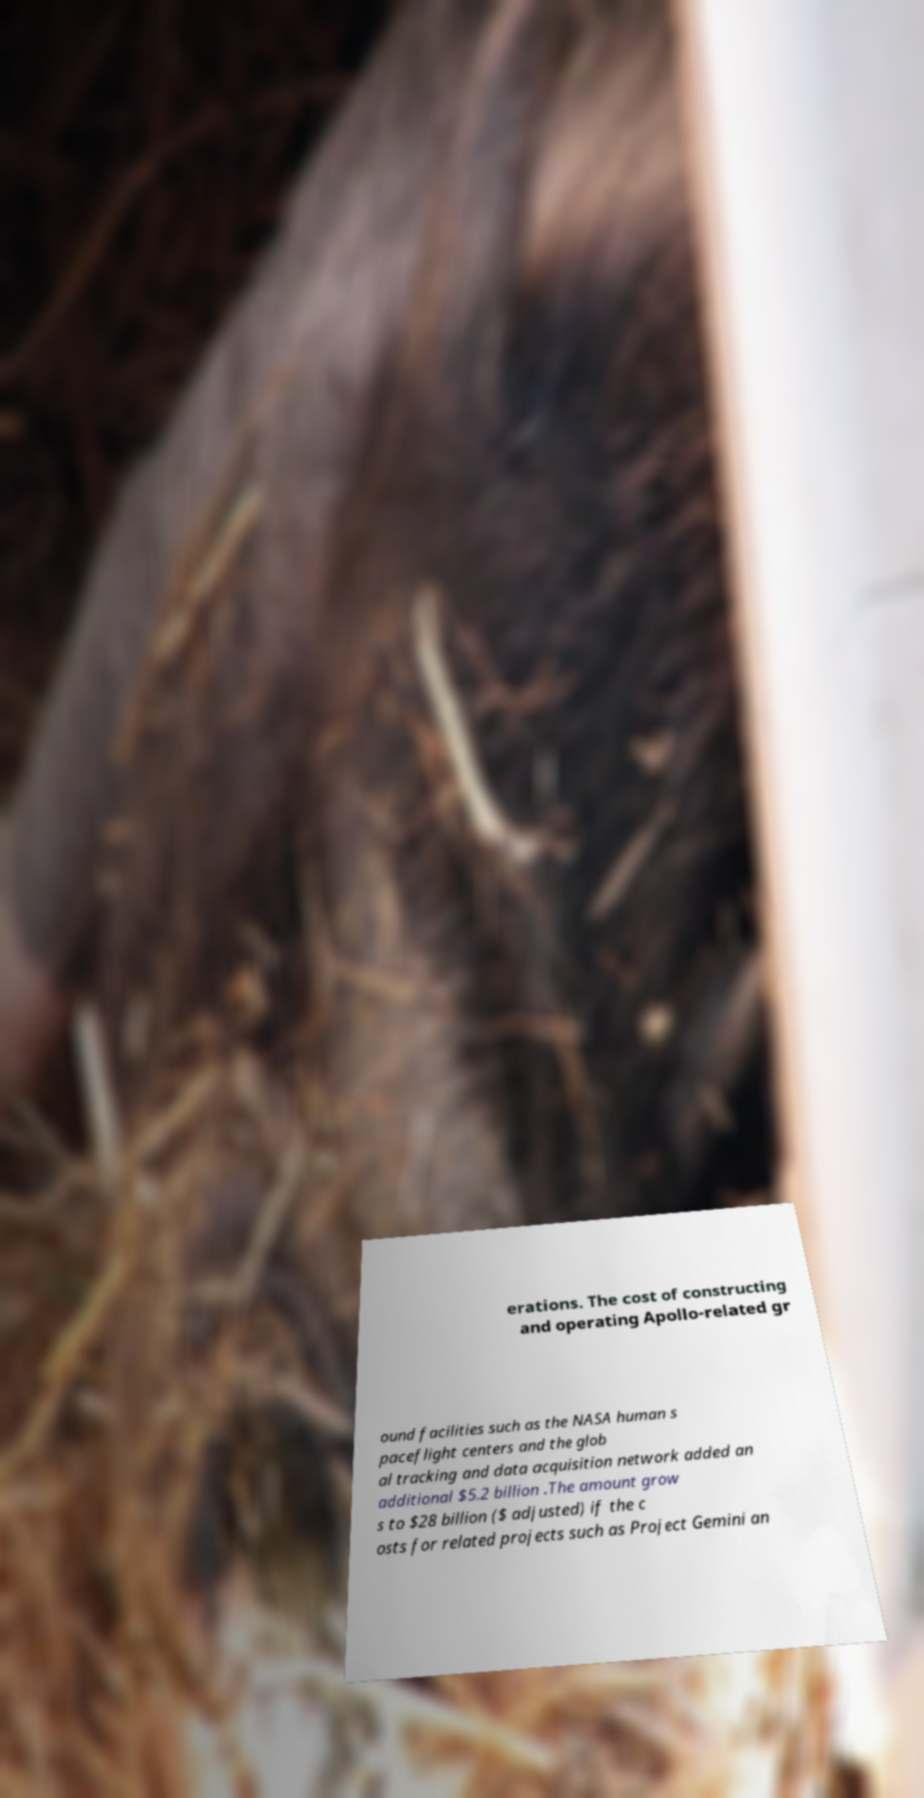I need the written content from this picture converted into text. Can you do that? erations. The cost of constructing and operating Apollo-related gr ound facilities such as the NASA human s paceflight centers and the glob al tracking and data acquisition network added an additional $5.2 billion .The amount grow s to $28 billion ($ adjusted) if the c osts for related projects such as Project Gemini an 